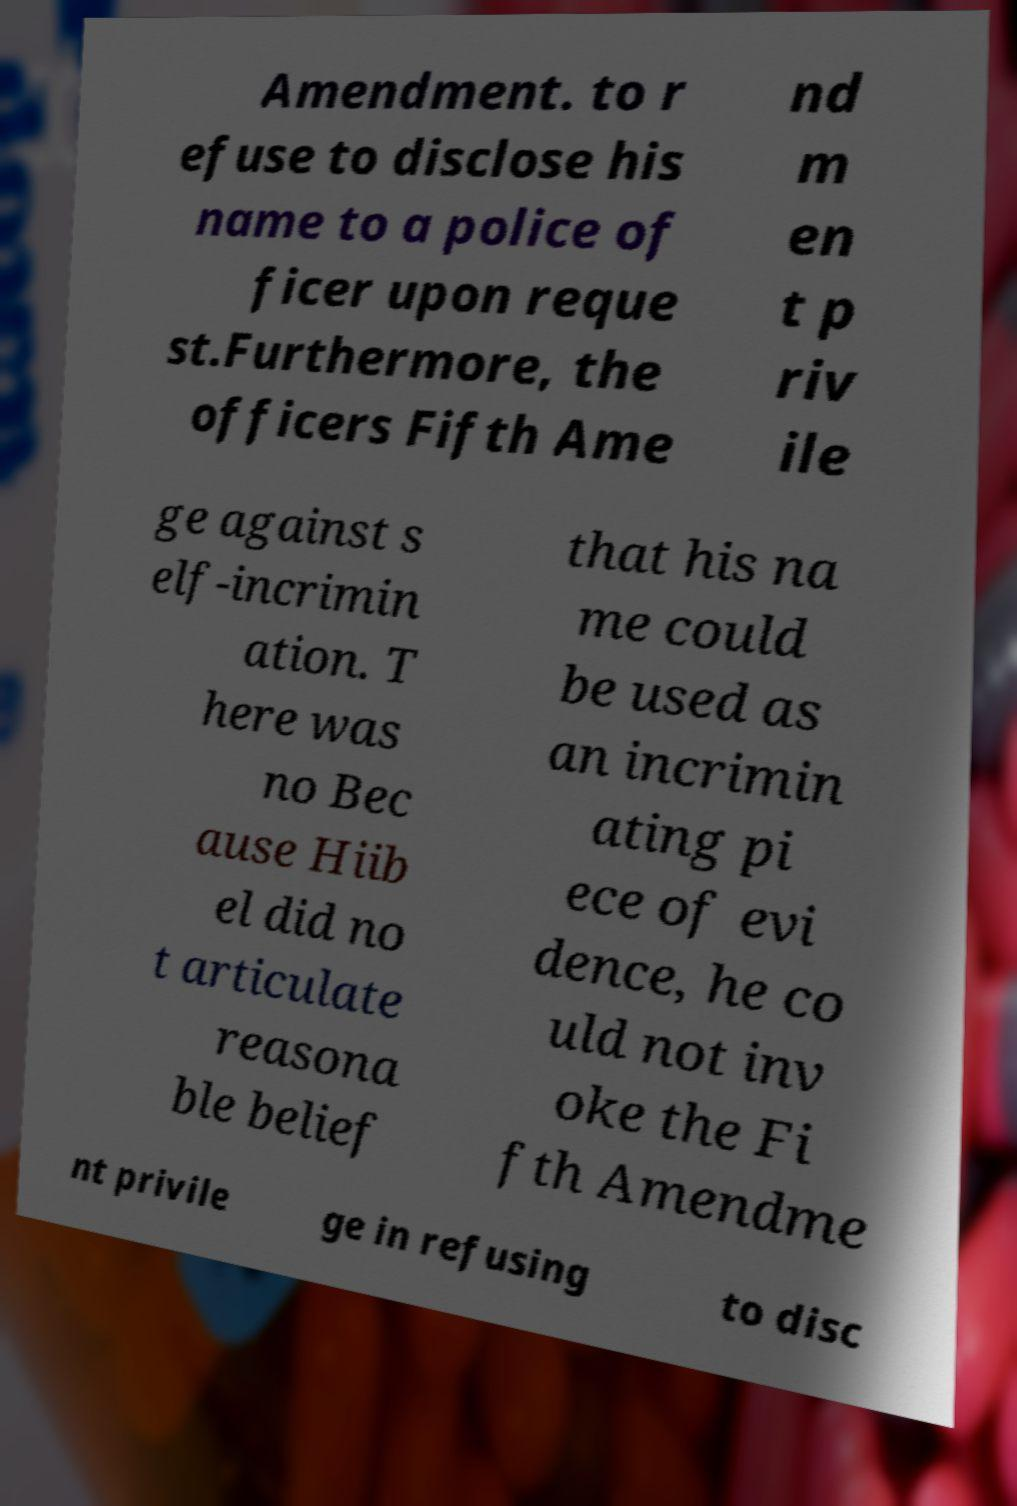Could you assist in decoding the text presented in this image and type it out clearly? Amendment. to r efuse to disclose his name to a police of ficer upon reque st.Furthermore, the officers Fifth Ame nd m en t p riv ile ge against s elf-incrimin ation. T here was no Bec ause Hiib el did no t articulate reasona ble belief that his na me could be used as an incrimin ating pi ece of evi dence, he co uld not inv oke the Fi fth Amendme nt privile ge in refusing to disc 